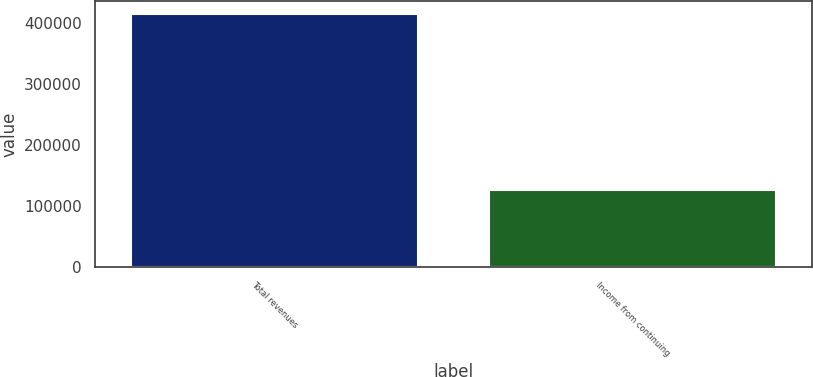<chart> <loc_0><loc_0><loc_500><loc_500><bar_chart><fcel>Total revenues<fcel>Income from continuing<nl><fcel>415852<fcel>125964<nl></chart> 